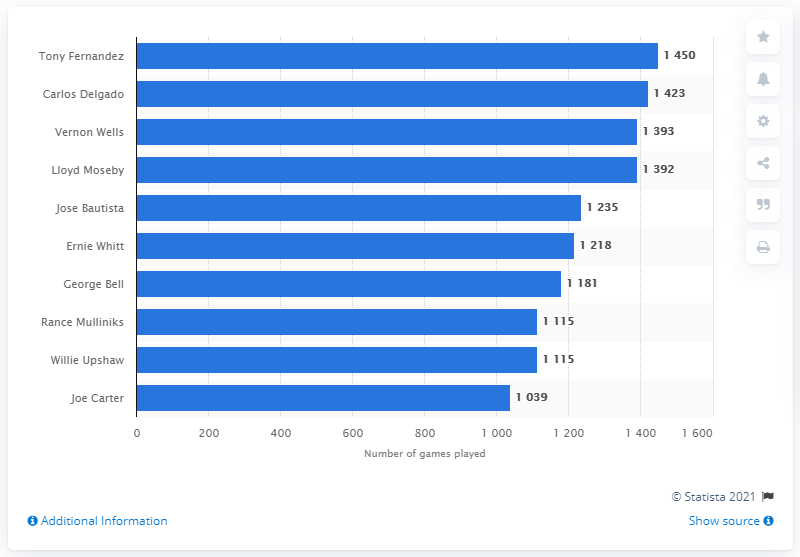Draw attention to some important aspects in this diagram. It is Tony Fernandez who has played the most games in the history of the Toronto Blue Jays franchise. 